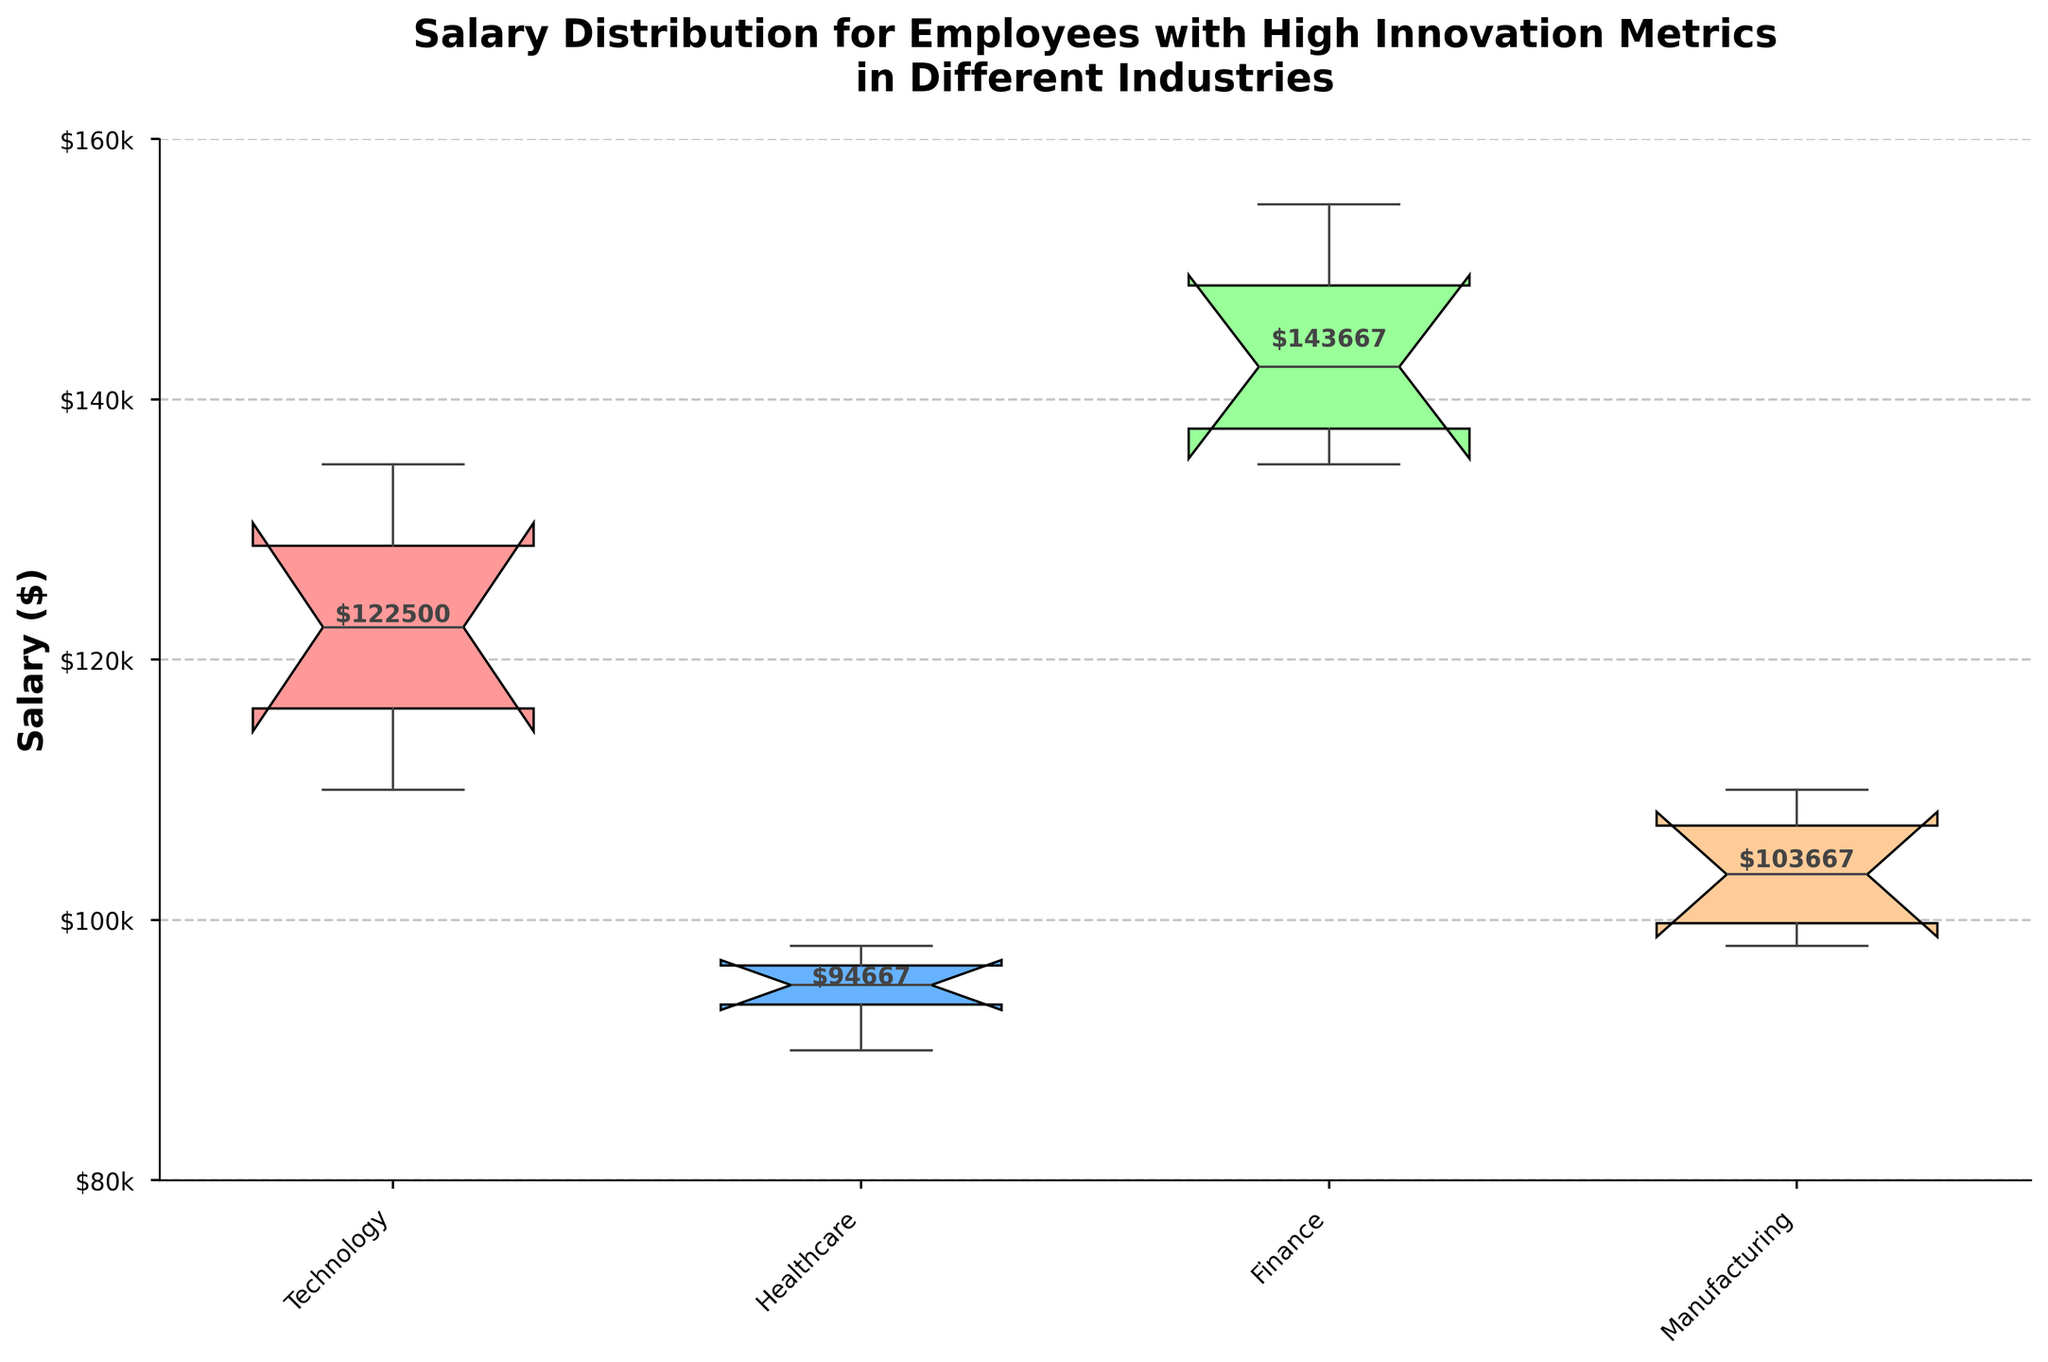What is the title of the figure? The title of the figure is located at the top and provides an overview of the visual representation. It reads "Salary Distribution for Employees with High Innovation Metrics in Different Industries".
Answer: Salary Distribution for Employees with High Innovation Metrics in Different Industries What industries are presented in the figure? The x-axis shows the names of the industries. They are Technology, Healthcare, Finance, and Manufacturing.
Answer: Technology, Healthcare, Finance, Manufacturing What does the y-axis represent? The y-axis represents the salary amounts in dollars for employees with high innovation metrics. It goes from $80,000 to $160,000 with ticks every $20k.
Answer: Salary ($) Which industry has the highest median salary? The median salaries are indicated by the horizontal lines inside the rectangular boxes for each industry. The highest median salary is in the Finance industry.
Answer: Finance What is the approximate interquartile range (IQR) for the Technology industry? The IQR is the difference between the upper quartile (top edge of the box) and the lower quartile (bottom edge of the box). For Technology, this range appears to be approximately $20,000.
Answer: $20,000 What is the average salary for the Healthcare industry? The figure has text annotations showing the average salary for each industry. For Healthcare, the text below the x-axis labels indicates the average salary is $95,500.
Answer: $95,500 Which industry has the widest spread in salary distribution? The spread of the salary distribution is indicated by the length of the whiskers. The Finance industry, with whiskers extending from around $135,000 to $155,000, has the widest spread.
Answer: Finance Are there any outliers in the salary distributions? Outliers in a box plot are typically indicated by points outside the whiskers. In this figure, no such points are visible, so there are no outliers.
Answer: No How does the median salary of the Manufacturing industry compare to the median salary of the Healthcare industry? The median line for Manufacturing is slightly lower compared to Healthcare. Thus, the median salary of Healthcare is slightly higher than Manufacturing.
Answer: Healthcare is higher What can be inferred about the salary distribution in the Technology industry compared to the Finance industry? The box in the Technology industry is more compact with a smaller IQR and lower median compared to the Finance industry, which indicates a tighter and lower salary distribution range.
Answer: More compact and lower in Technology 